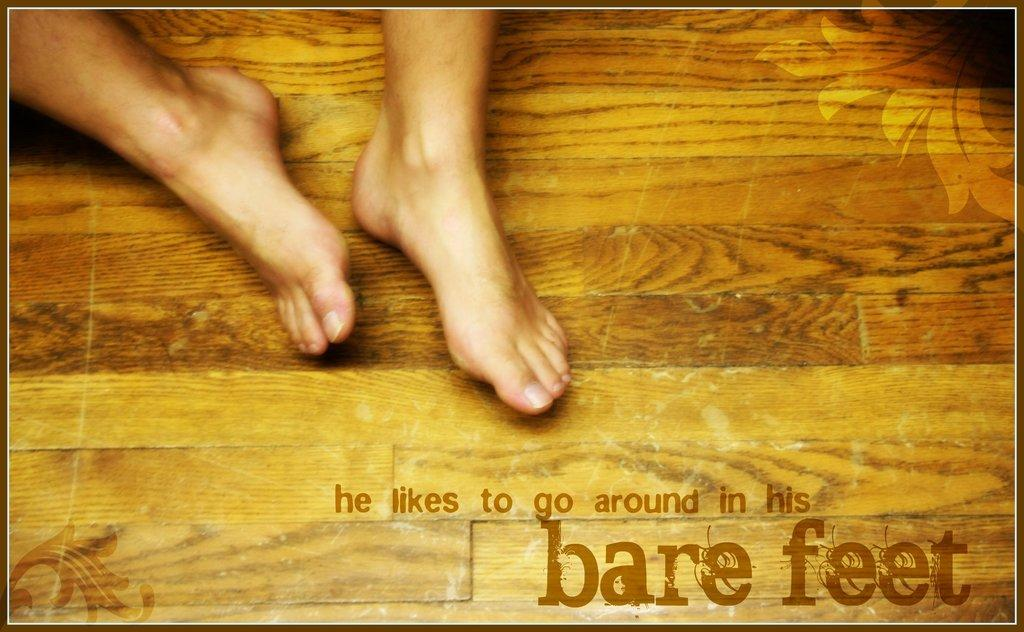<image>
Summarize the visual content of the image. A person's feet are bare, and the text reads, "he likes to go around in his bare feet". 